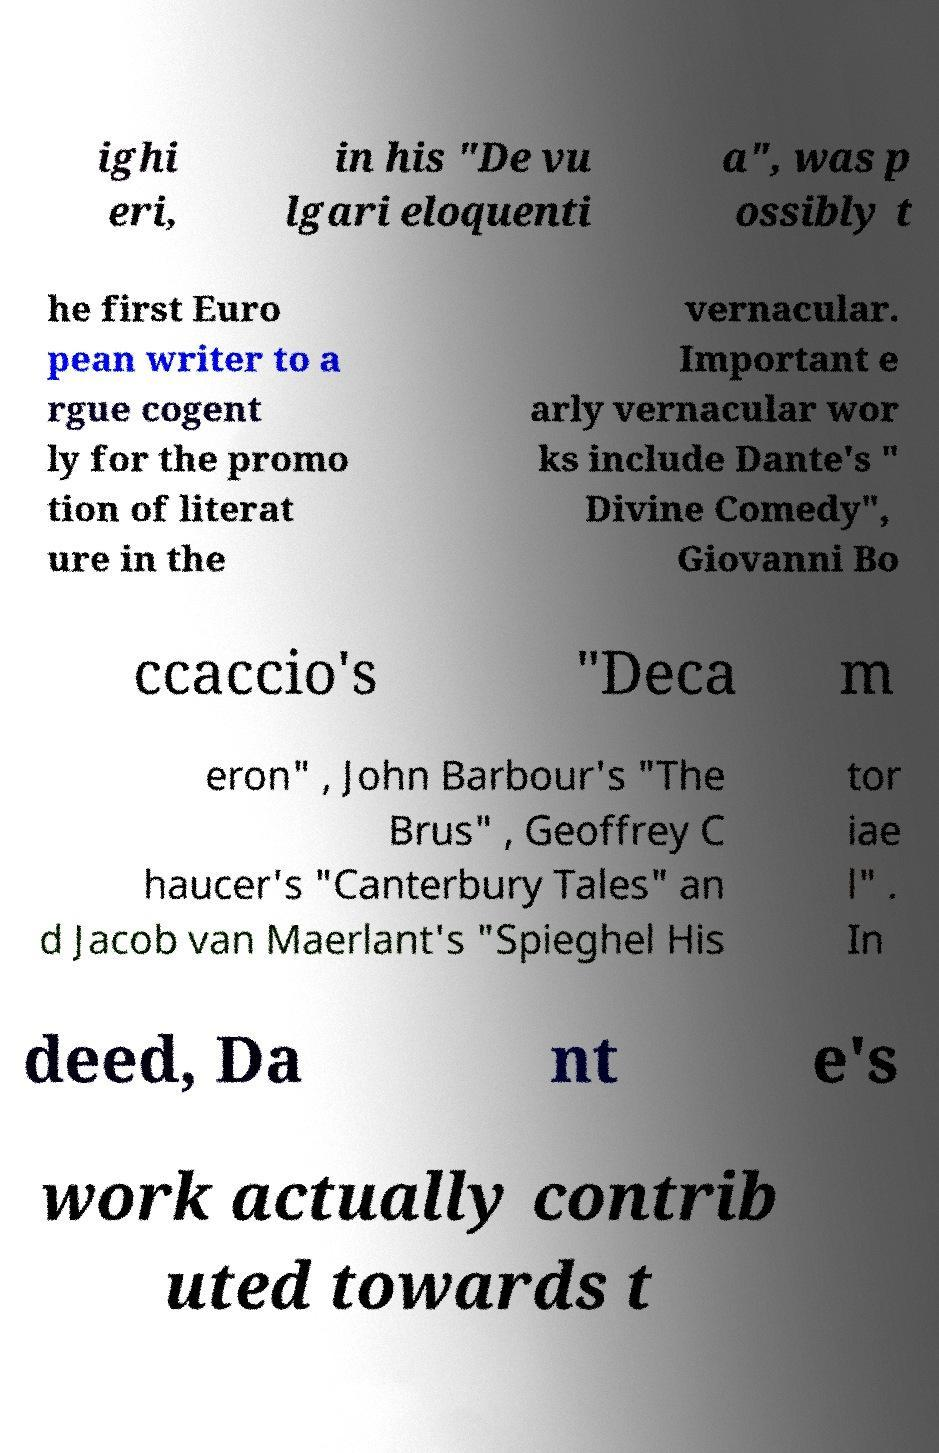Please identify and transcribe the text found in this image. ighi eri, in his "De vu lgari eloquenti a", was p ossibly t he first Euro pean writer to a rgue cogent ly for the promo tion of literat ure in the vernacular. Important e arly vernacular wor ks include Dante's " Divine Comedy", Giovanni Bo ccaccio's "Deca m eron" , John Barbour's "The Brus" , Geoffrey C haucer's "Canterbury Tales" an d Jacob van Maerlant's "Spieghel His tor iae l" . In deed, Da nt e's work actually contrib uted towards t 